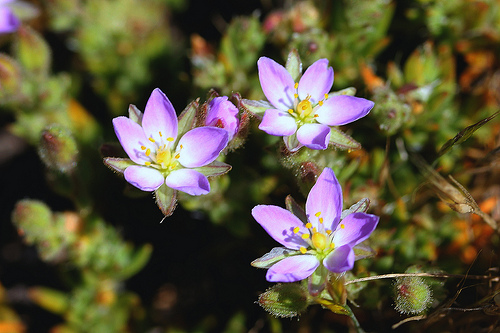<image>
Is the flower next to the flower? Yes. The flower is positioned adjacent to the flower, located nearby in the same general area. 